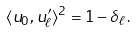Convert formula to latex. <formula><loc_0><loc_0><loc_500><loc_500>\langle u _ { 0 } , u ^ { \prime } _ { \ell } \rangle ^ { 2 } = 1 - \delta _ { \ell } \, .</formula> 